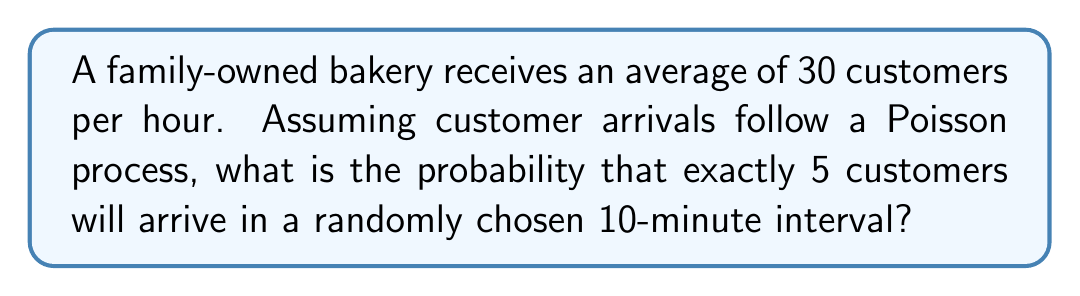What is the answer to this math problem? To solve this problem, we'll use the Poisson distribution formula and follow these steps:

1. Calculate the average number of arrivals (λ) for a 10-minute interval:
   λ = (30 customers/hour) × (1 hour/60 minutes) × (10 minutes) = 5 customers

2. Use the Poisson probability mass function:
   $$P(X = k) = \frac{e^{-\lambda}\lambda^k}{k!}$$
   where X is the number of events, k is the specific number we're interested in, 
   e is Euler's number, and λ is the average number of events in the interval.

3. Plug in the values:
   $$P(X = 5) = \frac{e^{-5}5^5}{5!}$$

4. Calculate step by step:
   $$P(X = 5) = \frac{e^{-5} \times 3125}{120}$$
   $$\approx \frac{0.00673795 \times 3125}{120}$$
   $$\approx \frac{21.0560937}{120}$$
   $$\approx 0.1754674475$$

5. Round to 4 decimal places:
   P(X = 5) ≈ 0.1755

Therefore, the probability of exactly 5 customers arriving in a randomly chosen 10-minute interval is approximately 0.1755 or 17.55%.
Answer: 0.1755 